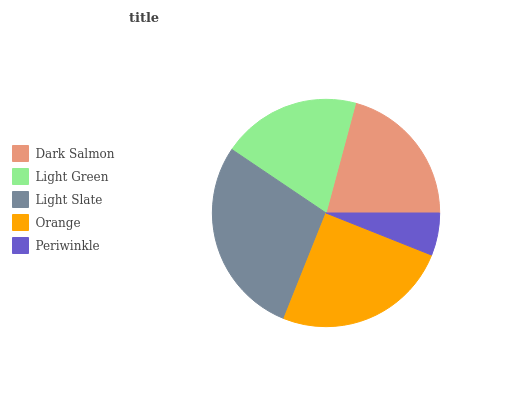Is Periwinkle the minimum?
Answer yes or no. Yes. Is Light Slate the maximum?
Answer yes or no. Yes. Is Light Green the minimum?
Answer yes or no. No. Is Light Green the maximum?
Answer yes or no. No. Is Dark Salmon greater than Light Green?
Answer yes or no. Yes. Is Light Green less than Dark Salmon?
Answer yes or no. Yes. Is Light Green greater than Dark Salmon?
Answer yes or no. No. Is Dark Salmon less than Light Green?
Answer yes or no. No. Is Dark Salmon the high median?
Answer yes or no. Yes. Is Dark Salmon the low median?
Answer yes or no. Yes. Is Light Green the high median?
Answer yes or no. No. Is Orange the low median?
Answer yes or no. No. 